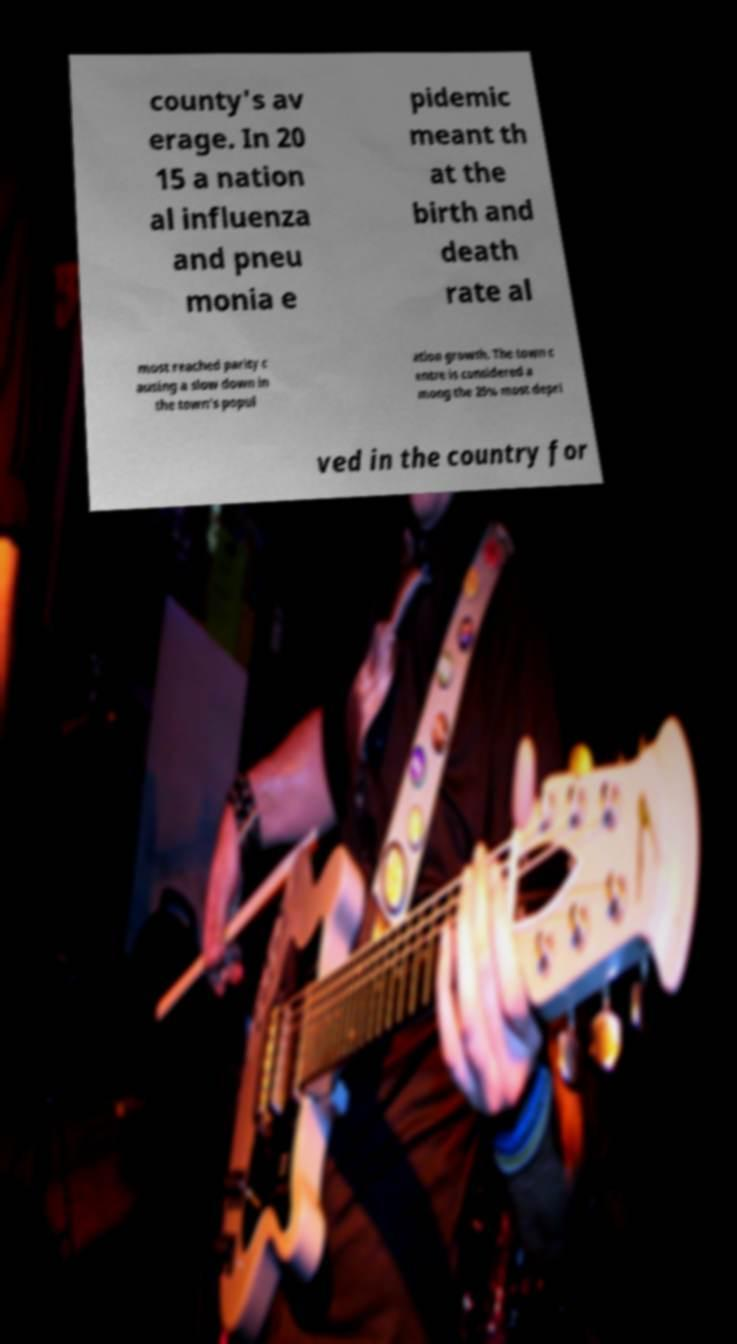For documentation purposes, I need the text within this image transcribed. Could you provide that? county's av erage. In 20 15 a nation al influenza and pneu monia e pidemic meant th at the birth and death rate al most reached parity c ausing a slow down in the town's popul ation growth. The town c entre is considered a mong the 25% most depri ved in the country for 